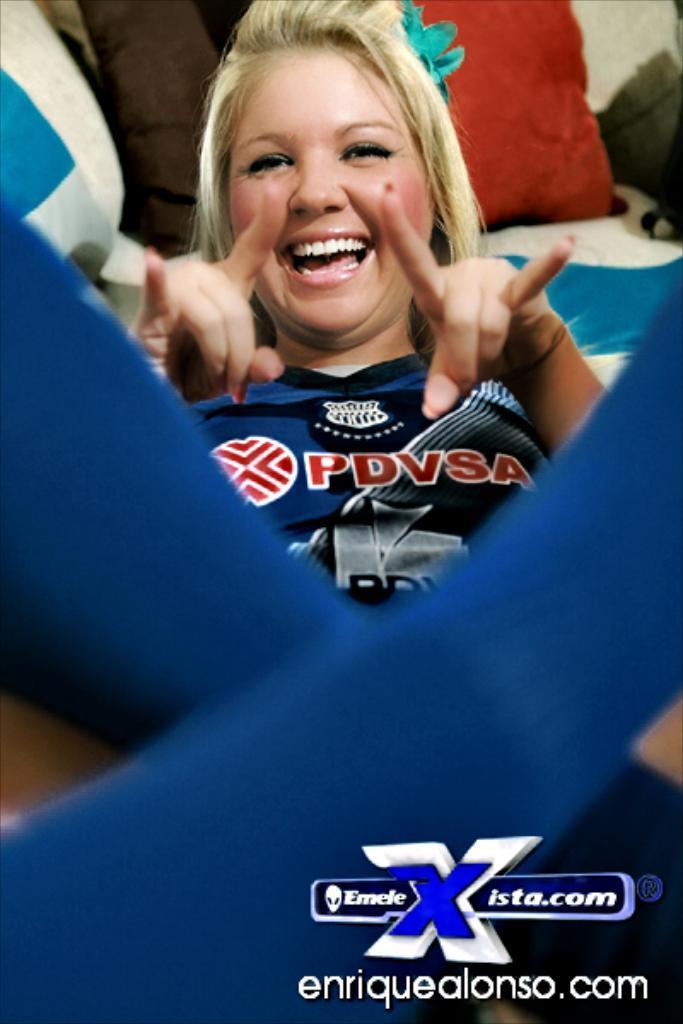Please provide a concise description of this image. In this image we can see a person and pillows in the background. 